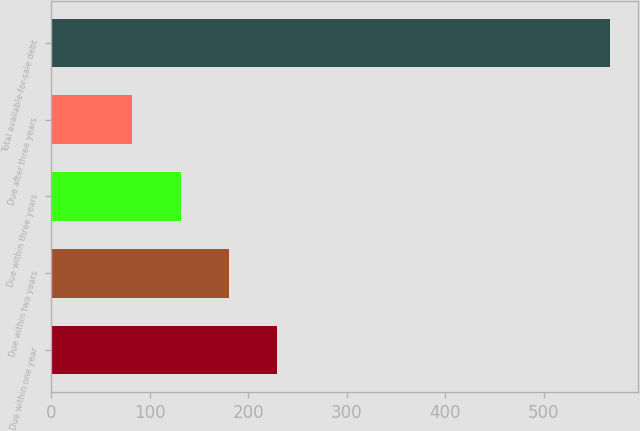Convert chart to OTSL. <chart><loc_0><loc_0><loc_500><loc_500><bar_chart><fcel>Due within one year<fcel>Due within two years<fcel>Due within three years<fcel>Due after three years<fcel>Total available-for-sale debt<nl><fcel>229<fcel>180.5<fcel>132<fcel>82<fcel>567<nl></chart> 